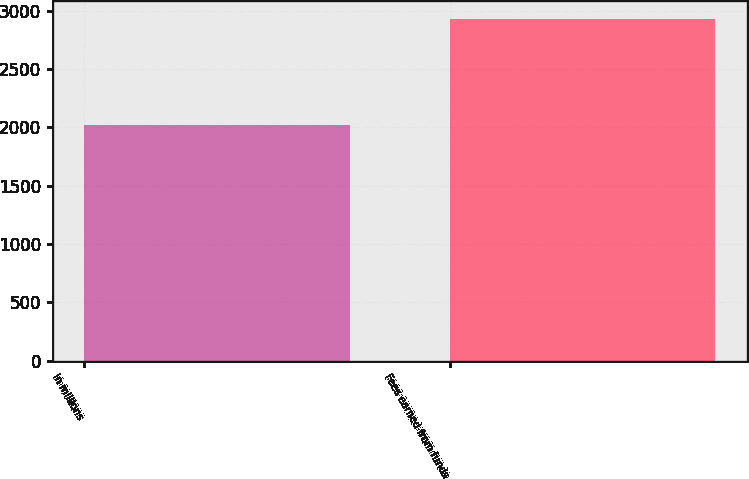Convert chart. <chart><loc_0><loc_0><loc_500><loc_500><bar_chart><fcel>in millions<fcel>Fees earned from funds<nl><fcel>2017<fcel>2932<nl></chart> 